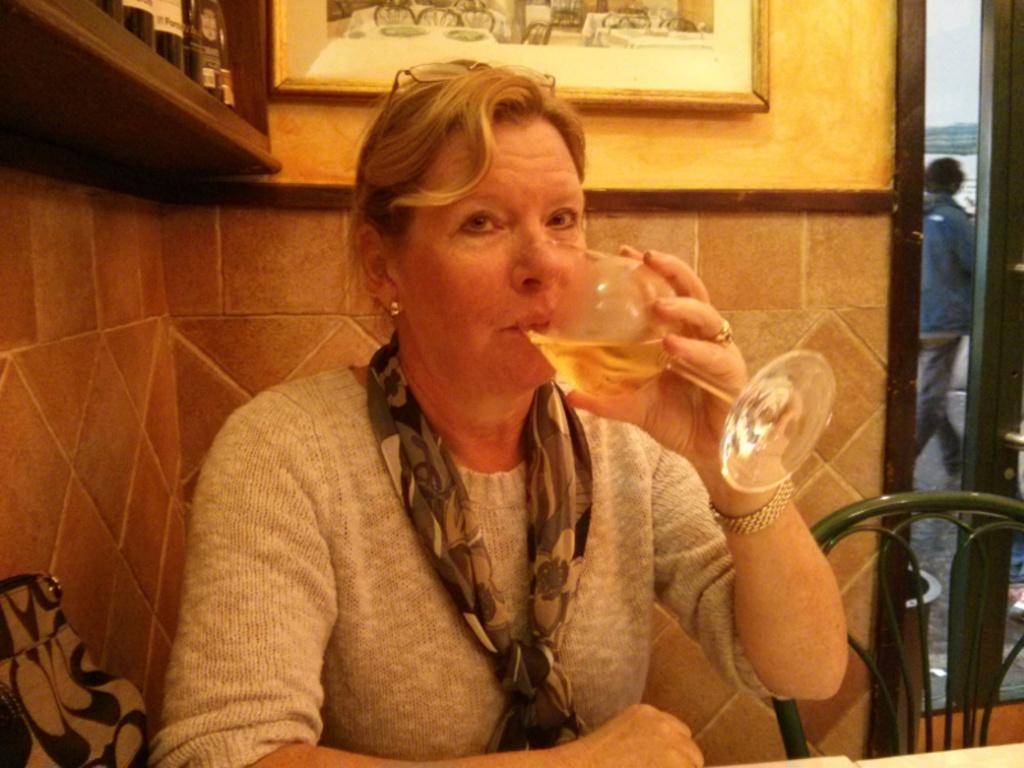Please provide a concise description of this image. In this image, we can see a woman sitting and she is drinking, there is a green color chair, in the background we can see a person walking. 